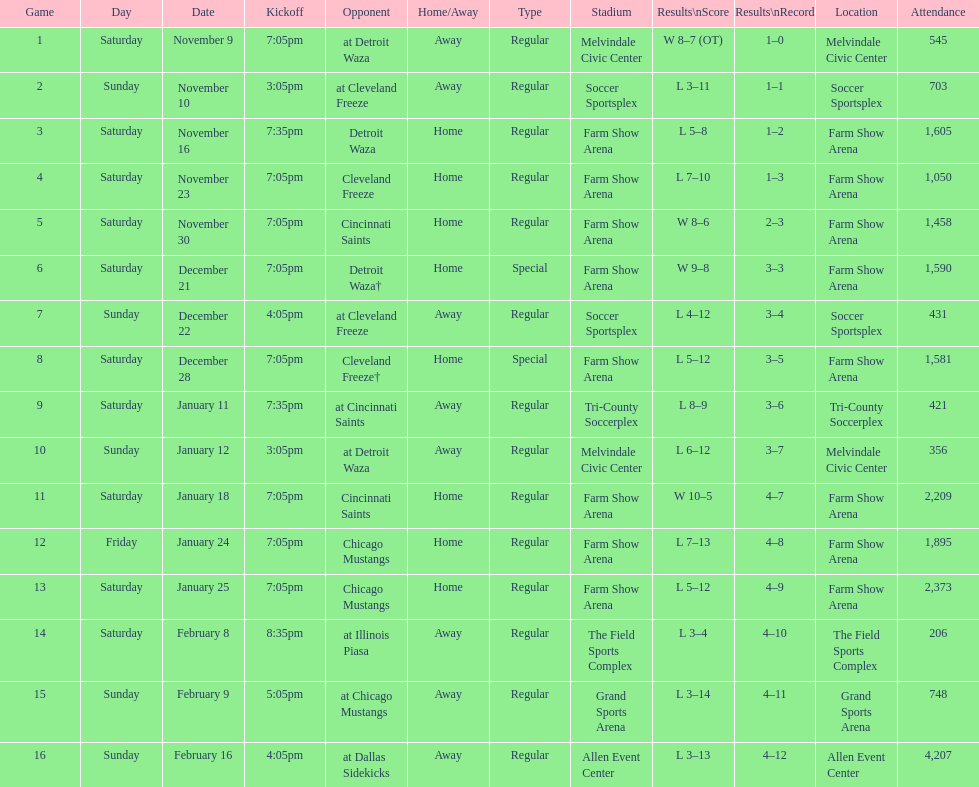What is the date of the game after december 22? December 28. 